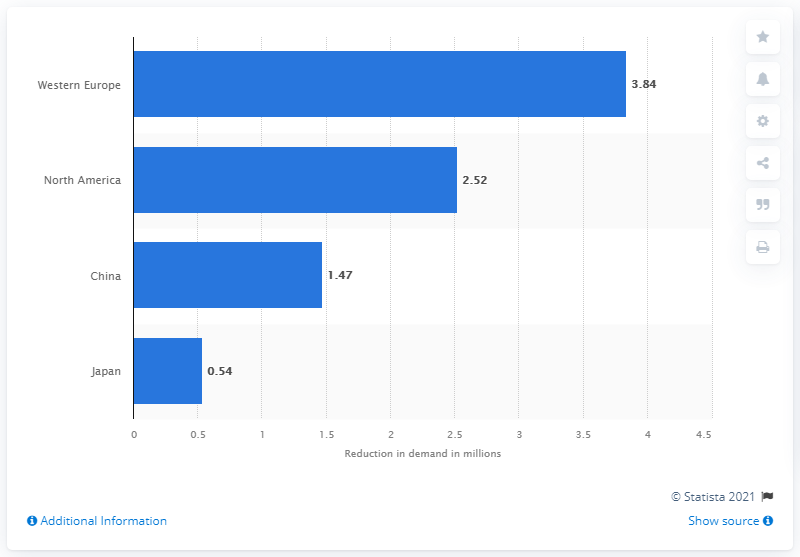Draw attention to some important aspects in this diagram. As of October 2020, North American auto demand was significantly below 2019 levels, with a total of 2.52 units. 